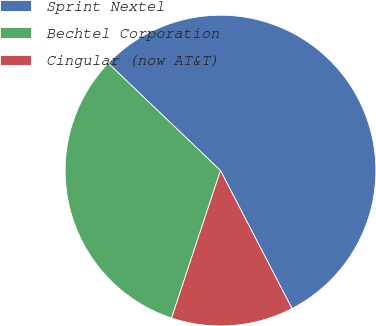<chart> <loc_0><loc_0><loc_500><loc_500><pie_chart><fcel>Sprint Nextel<fcel>Bechtel Corporation<fcel>Cingular (now AT&T)<nl><fcel>55.25%<fcel>32.04%<fcel>12.71%<nl></chart> 